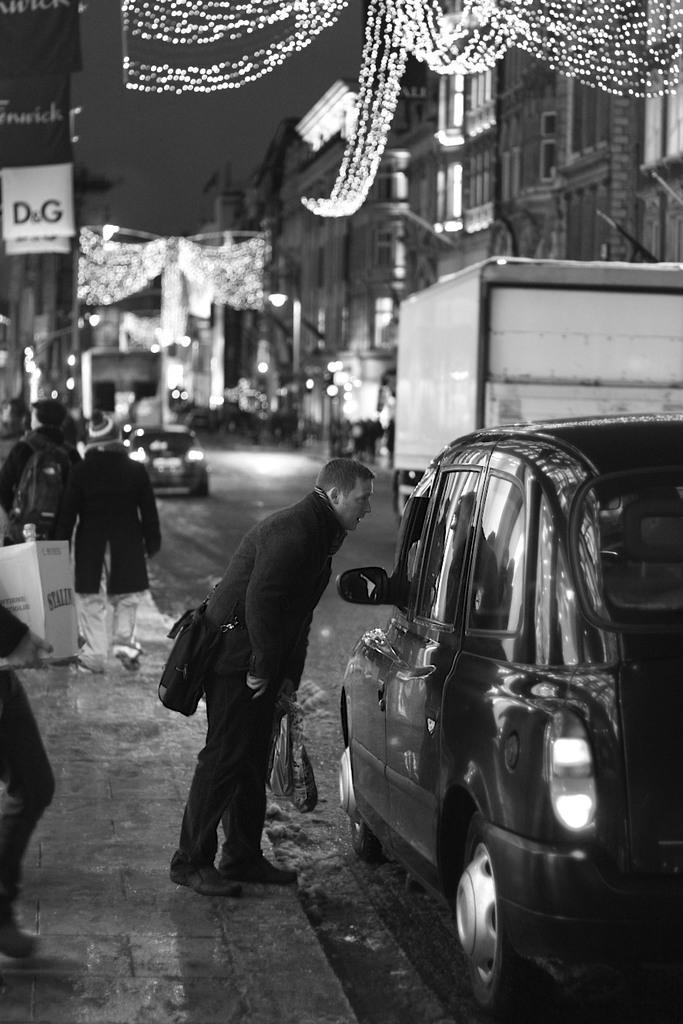What is the color scheme of the image? The image is black and white. What can be seen on the road in the image? There are vehicles on the road. What is happening with the group of people in the image? There is a group of people standing. What type of structures are present in the image? There are buildings in the image. What can be seen illuminating the scene in the image? There are lights visible in the image. What type of cats can be seen interacting with the substance on the instrument in the image? There are no cats, substances, or instruments present in the image. 